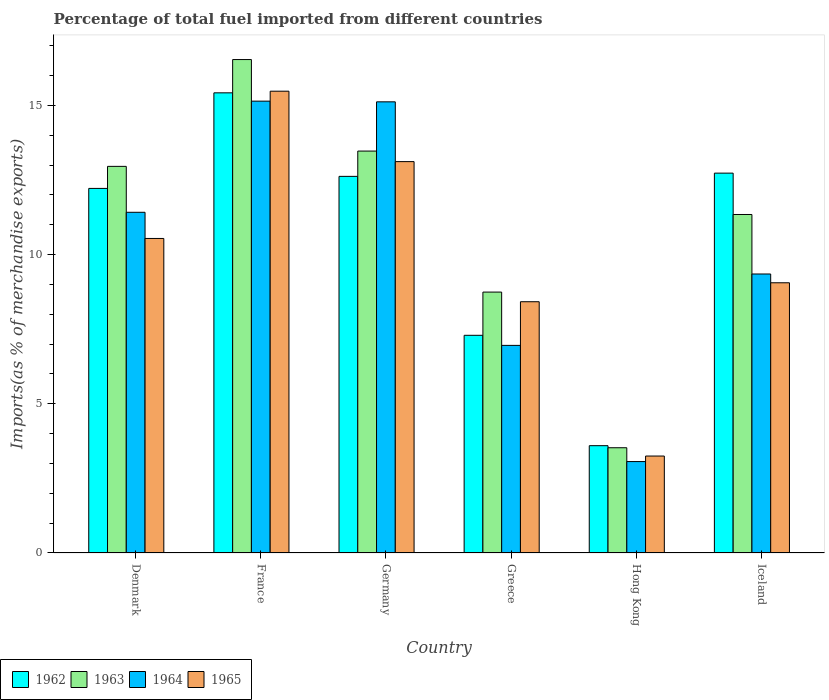How many different coloured bars are there?
Provide a short and direct response. 4. How many groups of bars are there?
Offer a very short reply. 6. How many bars are there on the 5th tick from the left?
Keep it short and to the point. 4. How many bars are there on the 5th tick from the right?
Provide a succinct answer. 4. What is the label of the 5th group of bars from the left?
Give a very brief answer. Hong Kong. In how many cases, is the number of bars for a given country not equal to the number of legend labels?
Your answer should be compact. 0. What is the percentage of imports to different countries in 1963 in Germany?
Your answer should be very brief. 13.47. Across all countries, what is the maximum percentage of imports to different countries in 1965?
Offer a terse response. 15.48. Across all countries, what is the minimum percentage of imports to different countries in 1964?
Your response must be concise. 3.06. In which country was the percentage of imports to different countries in 1962 maximum?
Your answer should be compact. France. In which country was the percentage of imports to different countries in 1962 minimum?
Ensure brevity in your answer.  Hong Kong. What is the total percentage of imports to different countries in 1964 in the graph?
Provide a short and direct response. 61.06. What is the difference between the percentage of imports to different countries in 1963 in Greece and that in Hong Kong?
Keep it short and to the point. 5.22. What is the difference between the percentage of imports to different countries in 1962 in Germany and the percentage of imports to different countries in 1963 in Iceland?
Give a very brief answer. 1.28. What is the average percentage of imports to different countries in 1964 per country?
Make the answer very short. 10.18. What is the difference between the percentage of imports to different countries of/in 1964 and percentage of imports to different countries of/in 1963 in France?
Provide a succinct answer. -1.39. In how many countries, is the percentage of imports to different countries in 1964 greater than 6 %?
Give a very brief answer. 5. What is the ratio of the percentage of imports to different countries in 1965 in Denmark to that in Iceland?
Make the answer very short. 1.16. Is the difference between the percentage of imports to different countries in 1964 in Denmark and Iceland greater than the difference between the percentage of imports to different countries in 1963 in Denmark and Iceland?
Your answer should be very brief. Yes. What is the difference between the highest and the second highest percentage of imports to different countries in 1962?
Provide a succinct answer. 0.11. What is the difference between the highest and the lowest percentage of imports to different countries in 1965?
Provide a succinct answer. 12.23. Is it the case that in every country, the sum of the percentage of imports to different countries in 1963 and percentage of imports to different countries in 1964 is greater than the sum of percentage of imports to different countries in 1962 and percentage of imports to different countries in 1965?
Your response must be concise. No. What does the 1st bar from the left in Greece represents?
Offer a very short reply. 1962. What does the 2nd bar from the right in Germany represents?
Your response must be concise. 1964. Does the graph contain any zero values?
Your answer should be very brief. No. Does the graph contain grids?
Make the answer very short. No. How many legend labels are there?
Ensure brevity in your answer.  4. How are the legend labels stacked?
Provide a short and direct response. Horizontal. What is the title of the graph?
Ensure brevity in your answer.  Percentage of total fuel imported from different countries. What is the label or title of the Y-axis?
Provide a short and direct response. Imports(as % of merchandise exports). What is the Imports(as % of merchandise exports) in 1962 in Denmark?
Your response must be concise. 12.22. What is the Imports(as % of merchandise exports) in 1963 in Denmark?
Make the answer very short. 12.96. What is the Imports(as % of merchandise exports) in 1964 in Denmark?
Your answer should be very brief. 11.42. What is the Imports(as % of merchandise exports) in 1965 in Denmark?
Provide a succinct answer. 10.54. What is the Imports(as % of merchandise exports) of 1962 in France?
Provide a short and direct response. 15.42. What is the Imports(as % of merchandise exports) of 1963 in France?
Keep it short and to the point. 16.54. What is the Imports(as % of merchandise exports) in 1964 in France?
Your response must be concise. 15.14. What is the Imports(as % of merchandise exports) in 1965 in France?
Offer a very short reply. 15.48. What is the Imports(as % of merchandise exports) in 1962 in Germany?
Offer a very short reply. 12.62. What is the Imports(as % of merchandise exports) of 1963 in Germany?
Your answer should be very brief. 13.47. What is the Imports(as % of merchandise exports) in 1964 in Germany?
Keep it short and to the point. 15.12. What is the Imports(as % of merchandise exports) of 1965 in Germany?
Your answer should be compact. 13.12. What is the Imports(as % of merchandise exports) of 1962 in Greece?
Provide a short and direct response. 7.3. What is the Imports(as % of merchandise exports) in 1963 in Greece?
Provide a short and direct response. 8.74. What is the Imports(as % of merchandise exports) in 1964 in Greece?
Make the answer very short. 6.96. What is the Imports(as % of merchandise exports) of 1965 in Greece?
Offer a terse response. 8.42. What is the Imports(as % of merchandise exports) in 1962 in Hong Kong?
Your response must be concise. 3.6. What is the Imports(as % of merchandise exports) of 1963 in Hong Kong?
Your answer should be compact. 3.53. What is the Imports(as % of merchandise exports) in 1964 in Hong Kong?
Your answer should be compact. 3.06. What is the Imports(as % of merchandise exports) of 1965 in Hong Kong?
Ensure brevity in your answer.  3.25. What is the Imports(as % of merchandise exports) of 1962 in Iceland?
Provide a succinct answer. 12.73. What is the Imports(as % of merchandise exports) in 1963 in Iceland?
Provide a succinct answer. 11.35. What is the Imports(as % of merchandise exports) of 1964 in Iceland?
Keep it short and to the point. 9.35. What is the Imports(as % of merchandise exports) in 1965 in Iceland?
Make the answer very short. 9.06. Across all countries, what is the maximum Imports(as % of merchandise exports) in 1962?
Offer a very short reply. 15.42. Across all countries, what is the maximum Imports(as % of merchandise exports) in 1963?
Offer a very short reply. 16.54. Across all countries, what is the maximum Imports(as % of merchandise exports) in 1964?
Keep it short and to the point. 15.14. Across all countries, what is the maximum Imports(as % of merchandise exports) in 1965?
Provide a succinct answer. 15.48. Across all countries, what is the minimum Imports(as % of merchandise exports) in 1962?
Your answer should be compact. 3.6. Across all countries, what is the minimum Imports(as % of merchandise exports) in 1963?
Give a very brief answer. 3.53. Across all countries, what is the minimum Imports(as % of merchandise exports) of 1964?
Offer a very short reply. 3.06. Across all countries, what is the minimum Imports(as % of merchandise exports) of 1965?
Ensure brevity in your answer.  3.25. What is the total Imports(as % of merchandise exports) in 1962 in the graph?
Ensure brevity in your answer.  63.89. What is the total Imports(as % of merchandise exports) of 1963 in the graph?
Keep it short and to the point. 66.58. What is the total Imports(as % of merchandise exports) of 1964 in the graph?
Offer a terse response. 61.06. What is the total Imports(as % of merchandise exports) of 1965 in the graph?
Give a very brief answer. 59.86. What is the difference between the Imports(as % of merchandise exports) in 1962 in Denmark and that in France?
Your answer should be compact. -3.2. What is the difference between the Imports(as % of merchandise exports) in 1963 in Denmark and that in France?
Offer a very short reply. -3.58. What is the difference between the Imports(as % of merchandise exports) of 1964 in Denmark and that in France?
Give a very brief answer. -3.72. What is the difference between the Imports(as % of merchandise exports) in 1965 in Denmark and that in France?
Offer a terse response. -4.94. What is the difference between the Imports(as % of merchandise exports) in 1962 in Denmark and that in Germany?
Your answer should be compact. -0.4. What is the difference between the Imports(as % of merchandise exports) in 1963 in Denmark and that in Germany?
Your answer should be very brief. -0.51. What is the difference between the Imports(as % of merchandise exports) in 1964 in Denmark and that in Germany?
Your response must be concise. -3.7. What is the difference between the Imports(as % of merchandise exports) in 1965 in Denmark and that in Germany?
Provide a succinct answer. -2.58. What is the difference between the Imports(as % of merchandise exports) in 1962 in Denmark and that in Greece?
Offer a very short reply. 4.92. What is the difference between the Imports(as % of merchandise exports) in 1963 in Denmark and that in Greece?
Keep it short and to the point. 4.21. What is the difference between the Imports(as % of merchandise exports) of 1964 in Denmark and that in Greece?
Keep it short and to the point. 4.46. What is the difference between the Imports(as % of merchandise exports) of 1965 in Denmark and that in Greece?
Provide a short and direct response. 2.12. What is the difference between the Imports(as % of merchandise exports) of 1962 in Denmark and that in Hong Kong?
Your response must be concise. 8.62. What is the difference between the Imports(as % of merchandise exports) in 1963 in Denmark and that in Hong Kong?
Offer a very short reply. 9.43. What is the difference between the Imports(as % of merchandise exports) of 1964 in Denmark and that in Hong Kong?
Ensure brevity in your answer.  8.36. What is the difference between the Imports(as % of merchandise exports) in 1965 in Denmark and that in Hong Kong?
Ensure brevity in your answer.  7.29. What is the difference between the Imports(as % of merchandise exports) in 1962 in Denmark and that in Iceland?
Your answer should be compact. -0.51. What is the difference between the Imports(as % of merchandise exports) of 1963 in Denmark and that in Iceland?
Offer a very short reply. 1.61. What is the difference between the Imports(as % of merchandise exports) in 1964 in Denmark and that in Iceland?
Offer a very short reply. 2.07. What is the difference between the Imports(as % of merchandise exports) in 1965 in Denmark and that in Iceland?
Make the answer very short. 1.49. What is the difference between the Imports(as % of merchandise exports) of 1962 in France and that in Germany?
Keep it short and to the point. 2.8. What is the difference between the Imports(as % of merchandise exports) in 1963 in France and that in Germany?
Give a very brief answer. 3.07. What is the difference between the Imports(as % of merchandise exports) of 1964 in France and that in Germany?
Offer a terse response. 0.02. What is the difference between the Imports(as % of merchandise exports) in 1965 in France and that in Germany?
Make the answer very short. 2.36. What is the difference between the Imports(as % of merchandise exports) of 1962 in France and that in Greece?
Your response must be concise. 8.13. What is the difference between the Imports(as % of merchandise exports) of 1963 in France and that in Greece?
Your response must be concise. 7.79. What is the difference between the Imports(as % of merchandise exports) in 1964 in France and that in Greece?
Your response must be concise. 8.19. What is the difference between the Imports(as % of merchandise exports) in 1965 in France and that in Greece?
Ensure brevity in your answer.  7.06. What is the difference between the Imports(as % of merchandise exports) of 1962 in France and that in Hong Kong?
Offer a very short reply. 11.83. What is the difference between the Imports(as % of merchandise exports) of 1963 in France and that in Hong Kong?
Your response must be concise. 13.01. What is the difference between the Imports(as % of merchandise exports) in 1964 in France and that in Hong Kong?
Make the answer very short. 12.08. What is the difference between the Imports(as % of merchandise exports) in 1965 in France and that in Hong Kong?
Provide a short and direct response. 12.23. What is the difference between the Imports(as % of merchandise exports) in 1962 in France and that in Iceland?
Keep it short and to the point. 2.69. What is the difference between the Imports(as % of merchandise exports) of 1963 in France and that in Iceland?
Your answer should be compact. 5.19. What is the difference between the Imports(as % of merchandise exports) in 1964 in France and that in Iceland?
Your response must be concise. 5.79. What is the difference between the Imports(as % of merchandise exports) of 1965 in France and that in Iceland?
Keep it short and to the point. 6.42. What is the difference between the Imports(as % of merchandise exports) in 1962 in Germany and that in Greece?
Keep it short and to the point. 5.33. What is the difference between the Imports(as % of merchandise exports) of 1963 in Germany and that in Greece?
Keep it short and to the point. 4.73. What is the difference between the Imports(as % of merchandise exports) in 1964 in Germany and that in Greece?
Give a very brief answer. 8.16. What is the difference between the Imports(as % of merchandise exports) in 1965 in Germany and that in Greece?
Keep it short and to the point. 4.7. What is the difference between the Imports(as % of merchandise exports) in 1962 in Germany and that in Hong Kong?
Ensure brevity in your answer.  9.03. What is the difference between the Imports(as % of merchandise exports) in 1963 in Germany and that in Hong Kong?
Offer a very short reply. 9.94. What is the difference between the Imports(as % of merchandise exports) in 1964 in Germany and that in Hong Kong?
Give a very brief answer. 12.06. What is the difference between the Imports(as % of merchandise exports) in 1965 in Germany and that in Hong Kong?
Keep it short and to the point. 9.87. What is the difference between the Imports(as % of merchandise exports) in 1962 in Germany and that in Iceland?
Provide a succinct answer. -0.11. What is the difference between the Imports(as % of merchandise exports) of 1963 in Germany and that in Iceland?
Your answer should be compact. 2.13. What is the difference between the Imports(as % of merchandise exports) of 1964 in Germany and that in Iceland?
Your answer should be very brief. 5.77. What is the difference between the Imports(as % of merchandise exports) of 1965 in Germany and that in Iceland?
Provide a short and direct response. 4.06. What is the difference between the Imports(as % of merchandise exports) in 1962 in Greece and that in Hong Kong?
Give a very brief answer. 3.7. What is the difference between the Imports(as % of merchandise exports) in 1963 in Greece and that in Hong Kong?
Your answer should be compact. 5.22. What is the difference between the Imports(as % of merchandise exports) in 1964 in Greece and that in Hong Kong?
Offer a very short reply. 3.89. What is the difference between the Imports(as % of merchandise exports) of 1965 in Greece and that in Hong Kong?
Provide a succinct answer. 5.17. What is the difference between the Imports(as % of merchandise exports) in 1962 in Greece and that in Iceland?
Your response must be concise. -5.44. What is the difference between the Imports(as % of merchandise exports) in 1963 in Greece and that in Iceland?
Give a very brief answer. -2.6. What is the difference between the Imports(as % of merchandise exports) in 1964 in Greece and that in Iceland?
Your answer should be compact. -2.39. What is the difference between the Imports(as % of merchandise exports) of 1965 in Greece and that in Iceland?
Keep it short and to the point. -0.64. What is the difference between the Imports(as % of merchandise exports) of 1962 in Hong Kong and that in Iceland?
Offer a very short reply. -9.13. What is the difference between the Imports(as % of merchandise exports) of 1963 in Hong Kong and that in Iceland?
Make the answer very short. -7.82. What is the difference between the Imports(as % of merchandise exports) in 1964 in Hong Kong and that in Iceland?
Give a very brief answer. -6.29. What is the difference between the Imports(as % of merchandise exports) in 1965 in Hong Kong and that in Iceland?
Provide a succinct answer. -5.81. What is the difference between the Imports(as % of merchandise exports) in 1962 in Denmark and the Imports(as % of merchandise exports) in 1963 in France?
Provide a succinct answer. -4.32. What is the difference between the Imports(as % of merchandise exports) of 1962 in Denmark and the Imports(as % of merchandise exports) of 1964 in France?
Your answer should be very brief. -2.92. What is the difference between the Imports(as % of merchandise exports) of 1962 in Denmark and the Imports(as % of merchandise exports) of 1965 in France?
Give a very brief answer. -3.26. What is the difference between the Imports(as % of merchandise exports) of 1963 in Denmark and the Imports(as % of merchandise exports) of 1964 in France?
Keep it short and to the point. -2.19. What is the difference between the Imports(as % of merchandise exports) of 1963 in Denmark and the Imports(as % of merchandise exports) of 1965 in France?
Provide a short and direct response. -2.52. What is the difference between the Imports(as % of merchandise exports) in 1964 in Denmark and the Imports(as % of merchandise exports) in 1965 in France?
Ensure brevity in your answer.  -4.06. What is the difference between the Imports(as % of merchandise exports) of 1962 in Denmark and the Imports(as % of merchandise exports) of 1963 in Germany?
Provide a short and direct response. -1.25. What is the difference between the Imports(as % of merchandise exports) of 1962 in Denmark and the Imports(as % of merchandise exports) of 1964 in Germany?
Keep it short and to the point. -2.9. What is the difference between the Imports(as % of merchandise exports) in 1962 in Denmark and the Imports(as % of merchandise exports) in 1965 in Germany?
Your answer should be compact. -0.9. What is the difference between the Imports(as % of merchandise exports) of 1963 in Denmark and the Imports(as % of merchandise exports) of 1964 in Germany?
Provide a succinct answer. -2.16. What is the difference between the Imports(as % of merchandise exports) in 1963 in Denmark and the Imports(as % of merchandise exports) in 1965 in Germany?
Your response must be concise. -0.16. What is the difference between the Imports(as % of merchandise exports) in 1964 in Denmark and the Imports(as % of merchandise exports) in 1965 in Germany?
Provide a succinct answer. -1.7. What is the difference between the Imports(as % of merchandise exports) of 1962 in Denmark and the Imports(as % of merchandise exports) of 1963 in Greece?
Ensure brevity in your answer.  3.48. What is the difference between the Imports(as % of merchandise exports) of 1962 in Denmark and the Imports(as % of merchandise exports) of 1964 in Greece?
Keep it short and to the point. 5.26. What is the difference between the Imports(as % of merchandise exports) in 1962 in Denmark and the Imports(as % of merchandise exports) in 1965 in Greece?
Keep it short and to the point. 3.8. What is the difference between the Imports(as % of merchandise exports) of 1963 in Denmark and the Imports(as % of merchandise exports) of 1964 in Greece?
Your answer should be very brief. 6. What is the difference between the Imports(as % of merchandise exports) in 1963 in Denmark and the Imports(as % of merchandise exports) in 1965 in Greece?
Make the answer very short. 4.54. What is the difference between the Imports(as % of merchandise exports) of 1964 in Denmark and the Imports(as % of merchandise exports) of 1965 in Greece?
Your response must be concise. 3. What is the difference between the Imports(as % of merchandise exports) in 1962 in Denmark and the Imports(as % of merchandise exports) in 1963 in Hong Kong?
Keep it short and to the point. 8.69. What is the difference between the Imports(as % of merchandise exports) in 1962 in Denmark and the Imports(as % of merchandise exports) in 1964 in Hong Kong?
Make the answer very short. 9.16. What is the difference between the Imports(as % of merchandise exports) of 1962 in Denmark and the Imports(as % of merchandise exports) of 1965 in Hong Kong?
Make the answer very short. 8.97. What is the difference between the Imports(as % of merchandise exports) in 1963 in Denmark and the Imports(as % of merchandise exports) in 1964 in Hong Kong?
Keep it short and to the point. 9.89. What is the difference between the Imports(as % of merchandise exports) of 1963 in Denmark and the Imports(as % of merchandise exports) of 1965 in Hong Kong?
Give a very brief answer. 9.71. What is the difference between the Imports(as % of merchandise exports) in 1964 in Denmark and the Imports(as % of merchandise exports) in 1965 in Hong Kong?
Provide a succinct answer. 8.17. What is the difference between the Imports(as % of merchandise exports) of 1962 in Denmark and the Imports(as % of merchandise exports) of 1963 in Iceland?
Your response must be concise. 0.87. What is the difference between the Imports(as % of merchandise exports) in 1962 in Denmark and the Imports(as % of merchandise exports) in 1964 in Iceland?
Offer a very short reply. 2.87. What is the difference between the Imports(as % of merchandise exports) in 1962 in Denmark and the Imports(as % of merchandise exports) in 1965 in Iceland?
Make the answer very short. 3.16. What is the difference between the Imports(as % of merchandise exports) of 1963 in Denmark and the Imports(as % of merchandise exports) of 1964 in Iceland?
Offer a terse response. 3.61. What is the difference between the Imports(as % of merchandise exports) in 1963 in Denmark and the Imports(as % of merchandise exports) in 1965 in Iceland?
Provide a short and direct response. 3.9. What is the difference between the Imports(as % of merchandise exports) in 1964 in Denmark and the Imports(as % of merchandise exports) in 1965 in Iceland?
Your answer should be compact. 2.36. What is the difference between the Imports(as % of merchandise exports) of 1962 in France and the Imports(as % of merchandise exports) of 1963 in Germany?
Offer a very short reply. 1.95. What is the difference between the Imports(as % of merchandise exports) in 1962 in France and the Imports(as % of merchandise exports) in 1964 in Germany?
Your answer should be compact. 0.3. What is the difference between the Imports(as % of merchandise exports) of 1962 in France and the Imports(as % of merchandise exports) of 1965 in Germany?
Provide a succinct answer. 2.31. What is the difference between the Imports(as % of merchandise exports) of 1963 in France and the Imports(as % of merchandise exports) of 1964 in Germany?
Your response must be concise. 1.42. What is the difference between the Imports(as % of merchandise exports) of 1963 in France and the Imports(as % of merchandise exports) of 1965 in Germany?
Offer a terse response. 3.42. What is the difference between the Imports(as % of merchandise exports) in 1964 in France and the Imports(as % of merchandise exports) in 1965 in Germany?
Your answer should be very brief. 2.03. What is the difference between the Imports(as % of merchandise exports) of 1962 in France and the Imports(as % of merchandise exports) of 1963 in Greece?
Make the answer very short. 6.68. What is the difference between the Imports(as % of merchandise exports) in 1962 in France and the Imports(as % of merchandise exports) in 1964 in Greece?
Provide a short and direct response. 8.46. What is the difference between the Imports(as % of merchandise exports) in 1962 in France and the Imports(as % of merchandise exports) in 1965 in Greece?
Keep it short and to the point. 7. What is the difference between the Imports(as % of merchandise exports) of 1963 in France and the Imports(as % of merchandise exports) of 1964 in Greece?
Ensure brevity in your answer.  9.58. What is the difference between the Imports(as % of merchandise exports) in 1963 in France and the Imports(as % of merchandise exports) in 1965 in Greece?
Your answer should be compact. 8.12. What is the difference between the Imports(as % of merchandise exports) in 1964 in France and the Imports(as % of merchandise exports) in 1965 in Greece?
Ensure brevity in your answer.  6.72. What is the difference between the Imports(as % of merchandise exports) of 1962 in France and the Imports(as % of merchandise exports) of 1963 in Hong Kong?
Provide a succinct answer. 11.89. What is the difference between the Imports(as % of merchandise exports) of 1962 in France and the Imports(as % of merchandise exports) of 1964 in Hong Kong?
Make the answer very short. 12.36. What is the difference between the Imports(as % of merchandise exports) of 1962 in France and the Imports(as % of merchandise exports) of 1965 in Hong Kong?
Make the answer very short. 12.17. What is the difference between the Imports(as % of merchandise exports) of 1963 in France and the Imports(as % of merchandise exports) of 1964 in Hong Kong?
Provide a succinct answer. 13.47. What is the difference between the Imports(as % of merchandise exports) in 1963 in France and the Imports(as % of merchandise exports) in 1965 in Hong Kong?
Your answer should be compact. 13.29. What is the difference between the Imports(as % of merchandise exports) of 1964 in France and the Imports(as % of merchandise exports) of 1965 in Hong Kong?
Provide a succinct answer. 11.89. What is the difference between the Imports(as % of merchandise exports) in 1962 in France and the Imports(as % of merchandise exports) in 1963 in Iceland?
Keep it short and to the point. 4.08. What is the difference between the Imports(as % of merchandise exports) of 1962 in France and the Imports(as % of merchandise exports) of 1964 in Iceland?
Ensure brevity in your answer.  6.07. What is the difference between the Imports(as % of merchandise exports) of 1962 in France and the Imports(as % of merchandise exports) of 1965 in Iceland?
Make the answer very short. 6.37. What is the difference between the Imports(as % of merchandise exports) of 1963 in France and the Imports(as % of merchandise exports) of 1964 in Iceland?
Provide a short and direct response. 7.19. What is the difference between the Imports(as % of merchandise exports) of 1963 in France and the Imports(as % of merchandise exports) of 1965 in Iceland?
Keep it short and to the point. 7.48. What is the difference between the Imports(as % of merchandise exports) in 1964 in France and the Imports(as % of merchandise exports) in 1965 in Iceland?
Offer a terse response. 6.09. What is the difference between the Imports(as % of merchandise exports) of 1962 in Germany and the Imports(as % of merchandise exports) of 1963 in Greece?
Your response must be concise. 3.88. What is the difference between the Imports(as % of merchandise exports) in 1962 in Germany and the Imports(as % of merchandise exports) in 1964 in Greece?
Give a very brief answer. 5.66. What is the difference between the Imports(as % of merchandise exports) of 1962 in Germany and the Imports(as % of merchandise exports) of 1965 in Greece?
Your answer should be very brief. 4.2. What is the difference between the Imports(as % of merchandise exports) of 1963 in Germany and the Imports(as % of merchandise exports) of 1964 in Greece?
Ensure brevity in your answer.  6.51. What is the difference between the Imports(as % of merchandise exports) in 1963 in Germany and the Imports(as % of merchandise exports) in 1965 in Greece?
Your response must be concise. 5.05. What is the difference between the Imports(as % of merchandise exports) of 1964 in Germany and the Imports(as % of merchandise exports) of 1965 in Greece?
Make the answer very short. 6.7. What is the difference between the Imports(as % of merchandise exports) in 1962 in Germany and the Imports(as % of merchandise exports) in 1963 in Hong Kong?
Give a very brief answer. 9.1. What is the difference between the Imports(as % of merchandise exports) in 1962 in Germany and the Imports(as % of merchandise exports) in 1964 in Hong Kong?
Make the answer very short. 9.56. What is the difference between the Imports(as % of merchandise exports) in 1962 in Germany and the Imports(as % of merchandise exports) in 1965 in Hong Kong?
Your answer should be very brief. 9.37. What is the difference between the Imports(as % of merchandise exports) in 1963 in Germany and the Imports(as % of merchandise exports) in 1964 in Hong Kong?
Your response must be concise. 10.41. What is the difference between the Imports(as % of merchandise exports) of 1963 in Germany and the Imports(as % of merchandise exports) of 1965 in Hong Kong?
Make the answer very short. 10.22. What is the difference between the Imports(as % of merchandise exports) of 1964 in Germany and the Imports(as % of merchandise exports) of 1965 in Hong Kong?
Provide a succinct answer. 11.87. What is the difference between the Imports(as % of merchandise exports) in 1962 in Germany and the Imports(as % of merchandise exports) in 1963 in Iceland?
Your response must be concise. 1.28. What is the difference between the Imports(as % of merchandise exports) in 1962 in Germany and the Imports(as % of merchandise exports) in 1964 in Iceland?
Your response must be concise. 3.27. What is the difference between the Imports(as % of merchandise exports) of 1962 in Germany and the Imports(as % of merchandise exports) of 1965 in Iceland?
Offer a very short reply. 3.57. What is the difference between the Imports(as % of merchandise exports) in 1963 in Germany and the Imports(as % of merchandise exports) in 1964 in Iceland?
Give a very brief answer. 4.12. What is the difference between the Imports(as % of merchandise exports) of 1963 in Germany and the Imports(as % of merchandise exports) of 1965 in Iceland?
Keep it short and to the point. 4.41. What is the difference between the Imports(as % of merchandise exports) in 1964 in Germany and the Imports(as % of merchandise exports) in 1965 in Iceland?
Provide a succinct answer. 6.06. What is the difference between the Imports(as % of merchandise exports) in 1962 in Greece and the Imports(as % of merchandise exports) in 1963 in Hong Kong?
Offer a terse response. 3.77. What is the difference between the Imports(as % of merchandise exports) of 1962 in Greece and the Imports(as % of merchandise exports) of 1964 in Hong Kong?
Your answer should be compact. 4.23. What is the difference between the Imports(as % of merchandise exports) of 1962 in Greece and the Imports(as % of merchandise exports) of 1965 in Hong Kong?
Ensure brevity in your answer.  4.05. What is the difference between the Imports(as % of merchandise exports) in 1963 in Greece and the Imports(as % of merchandise exports) in 1964 in Hong Kong?
Your response must be concise. 5.68. What is the difference between the Imports(as % of merchandise exports) of 1963 in Greece and the Imports(as % of merchandise exports) of 1965 in Hong Kong?
Your answer should be very brief. 5.49. What is the difference between the Imports(as % of merchandise exports) of 1964 in Greece and the Imports(as % of merchandise exports) of 1965 in Hong Kong?
Offer a terse response. 3.71. What is the difference between the Imports(as % of merchandise exports) in 1962 in Greece and the Imports(as % of merchandise exports) in 1963 in Iceland?
Your answer should be compact. -4.05. What is the difference between the Imports(as % of merchandise exports) in 1962 in Greece and the Imports(as % of merchandise exports) in 1964 in Iceland?
Provide a succinct answer. -2.06. What is the difference between the Imports(as % of merchandise exports) of 1962 in Greece and the Imports(as % of merchandise exports) of 1965 in Iceland?
Your answer should be compact. -1.76. What is the difference between the Imports(as % of merchandise exports) in 1963 in Greece and the Imports(as % of merchandise exports) in 1964 in Iceland?
Give a very brief answer. -0.61. What is the difference between the Imports(as % of merchandise exports) in 1963 in Greece and the Imports(as % of merchandise exports) in 1965 in Iceland?
Ensure brevity in your answer.  -0.31. What is the difference between the Imports(as % of merchandise exports) in 1964 in Greece and the Imports(as % of merchandise exports) in 1965 in Iceland?
Provide a short and direct response. -2.1. What is the difference between the Imports(as % of merchandise exports) in 1962 in Hong Kong and the Imports(as % of merchandise exports) in 1963 in Iceland?
Your response must be concise. -7.75. What is the difference between the Imports(as % of merchandise exports) in 1962 in Hong Kong and the Imports(as % of merchandise exports) in 1964 in Iceland?
Ensure brevity in your answer.  -5.75. What is the difference between the Imports(as % of merchandise exports) in 1962 in Hong Kong and the Imports(as % of merchandise exports) in 1965 in Iceland?
Provide a succinct answer. -5.46. What is the difference between the Imports(as % of merchandise exports) in 1963 in Hong Kong and the Imports(as % of merchandise exports) in 1964 in Iceland?
Your answer should be compact. -5.82. What is the difference between the Imports(as % of merchandise exports) of 1963 in Hong Kong and the Imports(as % of merchandise exports) of 1965 in Iceland?
Provide a succinct answer. -5.53. What is the difference between the Imports(as % of merchandise exports) of 1964 in Hong Kong and the Imports(as % of merchandise exports) of 1965 in Iceland?
Give a very brief answer. -5.99. What is the average Imports(as % of merchandise exports) in 1962 per country?
Keep it short and to the point. 10.65. What is the average Imports(as % of merchandise exports) of 1963 per country?
Offer a terse response. 11.1. What is the average Imports(as % of merchandise exports) in 1964 per country?
Keep it short and to the point. 10.18. What is the average Imports(as % of merchandise exports) in 1965 per country?
Offer a terse response. 9.98. What is the difference between the Imports(as % of merchandise exports) in 1962 and Imports(as % of merchandise exports) in 1963 in Denmark?
Keep it short and to the point. -0.74. What is the difference between the Imports(as % of merchandise exports) in 1962 and Imports(as % of merchandise exports) in 1964 in Denmark?
Offer a very short reply. 0.8. What is the difference between the Imports(as % of merchandise exports) of 1962 and Imports(as % of merchandise exports) of 1965 in Denmark?
Provide a short and direct response. 1.68. What is the difference between the Imports(as % of merchandise exports) of 1963 and Imports(as % of merchandise exports) of 1964 in Denmark?
Ensure brevity in your answer.  1.54. What is the difference between the Imports(as % of merchandise exports) of 1963 and Imports(as % of merchandise exports) of 1965 in Denmark?
Provide a succinct answer. 2.42. What is the difference between the Imports(as % of merchandise exports) of 1964 and Imports(as % of merchandise exports) of 1965 in Denmark?
Keep it short and to the point. 0.88. What is the difference between the Imports(as % of merchandise exports) of 1962 and Imports(as % of merchandise exports) of 1963 in France?
Your answer should be very brief. -1.12. What is the difference between the Imports(as % of merchandise exports) in 1962 and Imports(as % of merchandise exports) in 1964 in France?
Provide a succinct answer. 0.28. What is the difference between the Imports(as % of merchandise exports) of 1962 and Imports(as % of merchandise exports) of 1965 in France?
Ensure brevity in your answer.  -0.05. What is the difference between the Imports(as % of merchandise exports) of 1963 and Imports(as % of merchandise exports) of 1964 in France?
Your answer should be compact. 1.39. What is the difference between the Imports(as % of merchandise exports) of 1963 and Imports(as % of merchandise exports) of 1965 in France?
Provide a succinct answer. 1.06. What is the difference between the Imports(as % of merchandise exports) of 1964 and Imports(as % of merchandise exports) of 1965 in France?
Keep it short and to the point. -0.33. What is the difference between the Imports(as % of merchandise exports) in 1962 and Imports(as % of merchandise exports) in 1963 in Germany?
Offer a very short reply. -0.85. What is the difference between the Imports(as % of merchandise exports) in 1962 and Imports(as % of merchandise exports) in 1964 in Germany?
Your answer should be compact. -2.5. What is the difference between the Imports(as % of merchandise exports) in 1962 and Imports(as % of merchandise exports) in 1965 in Germany?
Provide a succinct answer. -0.49. What is the difference between the Imports(as % of merchandise exports) of 1963 and Imports(as % of merchandise exports) of 1964 in Germany?
Your response must be concise. -1.65. What is the difference between the Imports(as % of merchandise exports) in 1963 and Imports(as % of merchandise exports) in 1965 in Germany?
Your response must be concise. 0.35. What is the difference between the Imports(as % of merchandise exports) of 1964 and Imports(as % of merchandise exports) of 1965 in Germany?
Ensure brevity in your answer.  2. What is the difference between the Imports(as % of merchandise exports) in 1962 and Imports(as % of merchandise exports) in 1963 in Greece?
Keep it short and to the point. -1.45. What is the difference between the Imports(as % of merchandise exports) in 1962 and Imports(as % of merchandise exports) in 1964 in Greece?
Give a very brief answer. 0.34. What is the difference between the Imports(as % of merchandise exports) in 1962 and Imports(as % of merchandise exports) in 1965 in Greece?
Your answer should be compact. -1.13. What is the difference between the Imports(as % of merchandise exports) in 1963 and Imports(as % of merchandise exports) in 1964 in Greece?
Keep it short and to the point. 1.79. What is the difference between the Imports(as % of merchandise exports) in 1963 and Imports(as % of merchandise exports) in 1965 in Greece?
Offer a terse response. 0.32. What is the difference between the Imports(as % of merchandise exports) of 1964 and Imports(as % of merchandise exports) of 1965 in Greece?
Keep it short and to the point. -1.46. What is the difference between the Imports(as % of merchandise exports) in 1962 and Imports(as % of merchandise exports) in 1963 in Hong Kong?
Make the answer very short. 0.07. What is the difference between the Imports(as % of merchandise exports) in 1962 and Imports(as % of merchandise exports) in 1964 in Hong Kong?
Offer a very short reply. 0.53. What is the difference between the Imports(as % of merchandise exports) in 1962 and Imports(as % of merchandise exports) in 1965 in Hong Kong?
Provide a short and direct response. 0.35. What is the difference between the Imports(as % of merchandise exports) in 1963 and Imports(as % of merchandise exports) in 1964 in Hong Kong?
Provide a short and direct response. 0.46. What is the difference between the Imports(as % of merchandise exports) of 1963 and Imports(as % of merchandise exports) of 1965 in Hong Kong?
Offer a very short reply. 0.28. What is the difference between the Imports(as % of merchandise exports) in 1964 and Imports(as % of merchandise exports) in 1965 in Hong Kong?
Ensure brevity in your answer.  -0.19. What is the difference between the Imports(as % of merchandise exports) in 1962 and Imports(as % of merchandise exports) in 1963 in Iceland?
Offer a terse response. 1.39. What is the difference between the Imports(as % of merchandise exports) in 1962 and Imports(as % of merchandise exports) in 1964 in Iceland?
Keep it short and to the point. 3.38. What is the difference between the Imports(as % of merchandise exports) in 1962 and Imports(as % of merchandise exports) in 1965 in Iceland?
Your response must be concise. 3.67. What is the difference between the Imports(as % of merchandise exports) of 1963 and Imports(as % of merchandise exports) of 1964 in Iceland?
Provide a short and direct response. 1.99. What is the difference between the Imports(as % of merchandise exports) of 1963 and Imports(as % of merchandise exports) of 1965 in Iceland?
Keep it short and to the point. 2.29. What is the difference between the Imports(as % of merchandise exports) of 1964 and Imports(as % of merchandise exports) of 1965 in Iceland?
Your answer should be very brief. 0.29. What is the ratio of the Imports(as % of merchandise exports) in 1962 in Denmark to that in France?
Ensure brevity in your answer.  0.79. What is the ratio of the Imports(as % of merchandise exports) in 1963 in Denmark to that in France?
Offer a terse response. 0.78. What is the ratio of the Imports(as % of merchandise exports) of 1964 in Denmark to that in France?
Ensure brevity in your answer.  0.75. What is the ratio of the Imports(as % of merchandise exports) of 1965 in Denmark to that in France?
Provide a short and direct response. 0.68. What is the ratio of the Imports(as % of merchandise exports) in 1963 in Denmark to that in Germany?
Ensure brevity in your answer.  0.96. What is the ratio of the Imports(as % of merchandise exports) of 1964 in Denmark to that in Germany?
Provide a short and direct response. 0.76. What is the ratio of the Imports(as % of merchandise exports) of 1965 in Denmark to that in Germany?
Make the answer very short. 0.8. What is the ratio of the Imports(as % of merchandise exports) in 1962 in Denmark to that in Greece?
Your response must be concise. 1.67. What is the ratio of the Imports(as % of merchandise exports) in 1963 in Denmark to that in Greece?
Ensure brevity in your answer.  1.48. What is the ratio of the Imports(as % of merchandise exports) in 1964 in Denmark to that in Greece?
Keep it short and to the point. 1.64. What is the ratio of the Imports(as % of merchandise exports) of 1965 in Denmark to that in Greece?
Offer a very short reply. 1.25. What is the ratio of the Imports(as % of merchandise exports) in 1962 in Denmark to that in Hong Kong?
Your answer should be very brief. 3.4. What is the ratio of the Imports(as % of merchandise exports) in 1963 in Denmark to that in Hong Kong?
Your answer should be compact. 3.67. What is the ratio of the Imports(as % of merchandise exports) in 1964 in Denmark to that in Hong Kong?
Offer a very short reply. 3.73. What is the ratio of the Imports(as % of merchandise exports) in 1965 in Denmark to that in Hong Kong?
Your response must be concise. 3.24. What is the ratio of the Imports(as % of merchandise exports) in 1962 in Denmark to that in Iceland?
Offer a terse response. 0.96. What is the ratio of the Imports(as % of merchandise exports) of 1963 in Denmark to that in Iceland?
Give a very brief answer. 1.14. What is the ratio of the Imports(as % of merchandise exports) of 1964 in Denmark to that in Iceland?
Give a very brief answer. 1.22. What is the ratio of the Imports(as % of merchandise exports) of 1965 in Denmark to that in Iceland?
Keep it short and to the point. 1.16. What is the ratio of the Imports(as % of merchandise exports) in 1962 in France to that in Germany?
Offer a very short reply. 1.22. What is the ratio of the Imports(as % of merchandise exports) in 1963 in France to that in Germany?
Offer a very short reply. 1.23. What is the ratio of the Imports(as % of merchandise exports) in 1965 in France to that in Germany?
Your answer should be compact. 1.18. What is the ratio of the Imports(as % of merchandise exports) in 1962 in France to that in Greece?
Provide a succinct answer. 2.11. What is the ratio of the Imports(as % of merchandise exports) of 1963 in France to that in Greece?
Your answer should be compact. 1.89. What is the ratio of the Imports(as % of merchandise exports) of 1964 in France to that in Greece?
Offer a terse response. 2.18. What is the ratio of the Imports(as % of merchandise exports) of 1965 in France to that in Greece?
Ensure brevity in your answer.  1.84. What is the ratio of the Imports(as % of merchandise exports) of 1962 in France to that in Hong Kong?
Ensure brevity in your answer.  4.29. What is the ratio of the Imports(as % of merchandise exports) in 1963 in France to that in Hong Kong?
Give a very brief answer. 4.69. What is the ratio of the Imports(as % of merchandise exports) in 1964 in France to that in Hong Kong?
Offer a very short reply. 4.94. What is the ratio of the Imports(as % of merchandise exports) in 1965 in France to that in Hong Kong?
Offer a terse response. 4.76. What is the ratio of the Imports(as % of merchandise exports) in 1962 in France to that in Iceland?
Offer a terse response. 1.21. What is the ratio of the Imports(as % of merchandise exports) of 1963 in France to that in Iceland?
Your response must be concise. 1.46. What is the ratio of the Imports(as % of merchandise exports) in 1964 in France to that in Iceland?
Provide a short and direct response. 1.62. What is the ratio of the Imports(as % of merchandise exports) in 1965 in France to that in Iceland?
Make the answer very short. 1.71. What is the ratio of the Imports(as % of merchandise exports) in 1962 in Germany to that in Greece?
Your answer should be compact. 1.73. What is the ratio of the Imports(as % of merchandise exports) of 1963 in Germany to that in Greece?
Provide a succinct answer. 1.54. What is the ratio of the Imports(as % of merchandise exports) of 1964 in Germany to that in Greece?
Offer a very short reply. 2.17. What is the ratio of the Imports(as % of merchandise exports) of 1965 in Germany to that in Greece?
Your answer should be very brief. 1.56. What is the ratio of the Imports(as % of merchandise exports) in 1962 in Germany to that in Hong Kong?
Offer a terse response. 3.51. What is the ratio of the Imports(as % of merchandise exports) in 1963 in Germany to that in Hong Kong?
Your answer should be very brief. 3.82. What is the ratio of the Imports(as % of merchandise exports) of 1964 in Germany to that in Hong Kong?
Offer a terse response. 4.94. What is the ratio of the Imports(as % of merchandise exports) of 1965 in Germany to that in Hong Kong?
Offer a very short reply. 4.04. What is the ratio of the Imports(as % of merchandise exports) of 1962 in Germany to that in Iceland?
Your response must be concise. 0.99. What is the ratio of the Imports(as % of merchandise exports) of 1963 in Germany to that in Iceland?
Provide a succinct answer. 1.19. What is the ratio of the Imports(as % of merchandise exports) of 1964 in Germany to that in Iceland?
Offer a very short reply. 1.62. What is the ratio of the Imports(as % of merchandise exports) in 1965 in Germany to that in Iceland?
Offer a very short reply. 1.45. What is the ratio of the Imports(as % of merchandise exports) in 1962 in Greece to that in Hong Kong?
Provide a succinct answer. 2.03. What is the ratio of the Imports(as % of merchandise exports) in 1963 in Greece to that in Hong Kong?
Give a very brief answer. 2.48. What is the ratio of the Imports(as % of merchandise exports) of 1964 in Greece to that in Hong Kong?
Your answer should be compact. 2.27. What is the ratio of the Imports(as % of merchandise exports) of 1965 in Greece to that in Hong Kong?
Offer a very short reply. 2.59. What is the ratio of the Imports(as % of merchandise exports) in 1962 in Greece to that in Iceland?
Give a very brief answer. 0.57. What is the ratio of the Imports(as % of merchandise exports) in 1963 in Greece to that in Iceland?
Keep it short and to the point. 0.77. What is the ratio of the Imports(as % of merchandise exports) of 1964 in Greece to that in Iceland?
Your answer should be compact. 0.74. What is the ratio of the Imports(as % of merchandise exports) in 1965 in Greece to that in Iceland?
Offer a terse response. 0.93. What is the ratio of the Imports(as % of merchandise exports) in 1962 in Hong Kong to that in Iceland?
Give a very brief answer. 0.28. What is the ratio of the Imports(as % of merchandise exports) of 1963 in Hong Kong to that in Iceland?
Give a very brief answer. 0.31. What is the ratio of the Imports(as % of merchandise exports) of 1964 in Hong Kong to that in Iceland?
Give a very brief answer. 0.33. What is the ratio of the Imports(as % of merchandise exports) of 1965 in Hong Kong to that in Iceland?
Keep it short and to the point. 0.36. What is the difference between the highest and the second highest Imports(as % of merchandise exports) in 1962?
Give a very brief answer. 2.69. What is the difference between the highest and the second highest Imports(as % of merchandise exports) of 1963?
Provide a succinct answer. 3.07. What is the difference between the highest and the second highest Imports(as % of merchandise exports) of 1964?
Keep it short and to the point. 0.02. What is the difference between the highest and the second highest Imports(as % of merchandise exports) in 1965?
Ensure brevity in your answer.  2.36. What is the difference between the highest and the lowest Imports(as % of merchandise exports) of 1962?
Offer a terse response. 11.83. What is the difference between the highest and the lowest Imports(as % of merchandise exports) of 1963?
Your answer should be very brief. 13.01. What is the difference between the highest and the lowest Imports(as % of merchandise exports) of 1964?
Keep it short and to the point. 12.08. What is the difference between the highest and the lowest Imports(as % of merchandise exports) in 1965?
Provide a short and direct response. 12.23. 